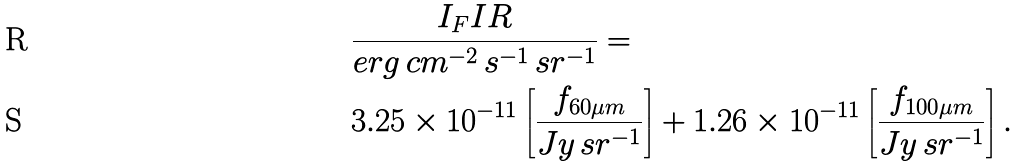Convert formula to latex. <formula><loc_0><loc_0><loc_500><loc_500>& \frac { I _ { F } I R } { e r g \, c m ^ { - 2 } \, s ^ { - 1 } \, s r ^ { - 1 } } = \\ & 3 . 2 5 \times 1 0 ^ { - 1 1 } \left [ \frac { f _ { 6 0 \mu m } } { J y \, s r ^ { - 1 } } \right ] + 1 . 2 6 \times 1 0 ^ { - 1 1 } \left [ \frac { f _ { 1 0 0 \mu m } } { J y \, s r ^ { - 1 } } \right ] .</formula> 